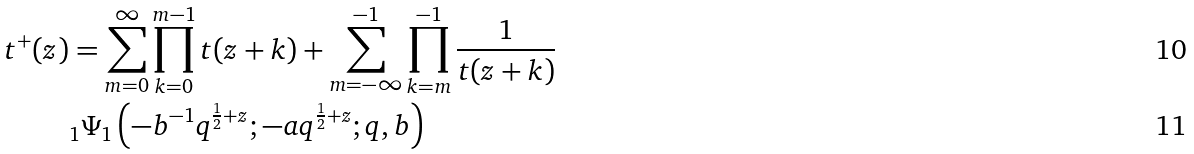<formula> <loc_0><loc_0><loc_500><loc_500>t ^ { + } ( z ) & = \sum _ { m = 0 } ^ { \infty } \prod _ { k = 0 } ^ { m - 1 } t ( z + k ) + \sum _ { m = - \infty } ^ { - 1 } \prod _ { k = m } ^ { - 1 } \frac { 1 } { t ( z + k ) } \\ & _ { 1 } \Psi _ { 1 } \left ( - b ^ { - 1 } q ^ { \frac { 1 } { 2 } + z } ; - a q ^ { \frac { 1 } { 2 } + z } ; q , b \right )</formula> 